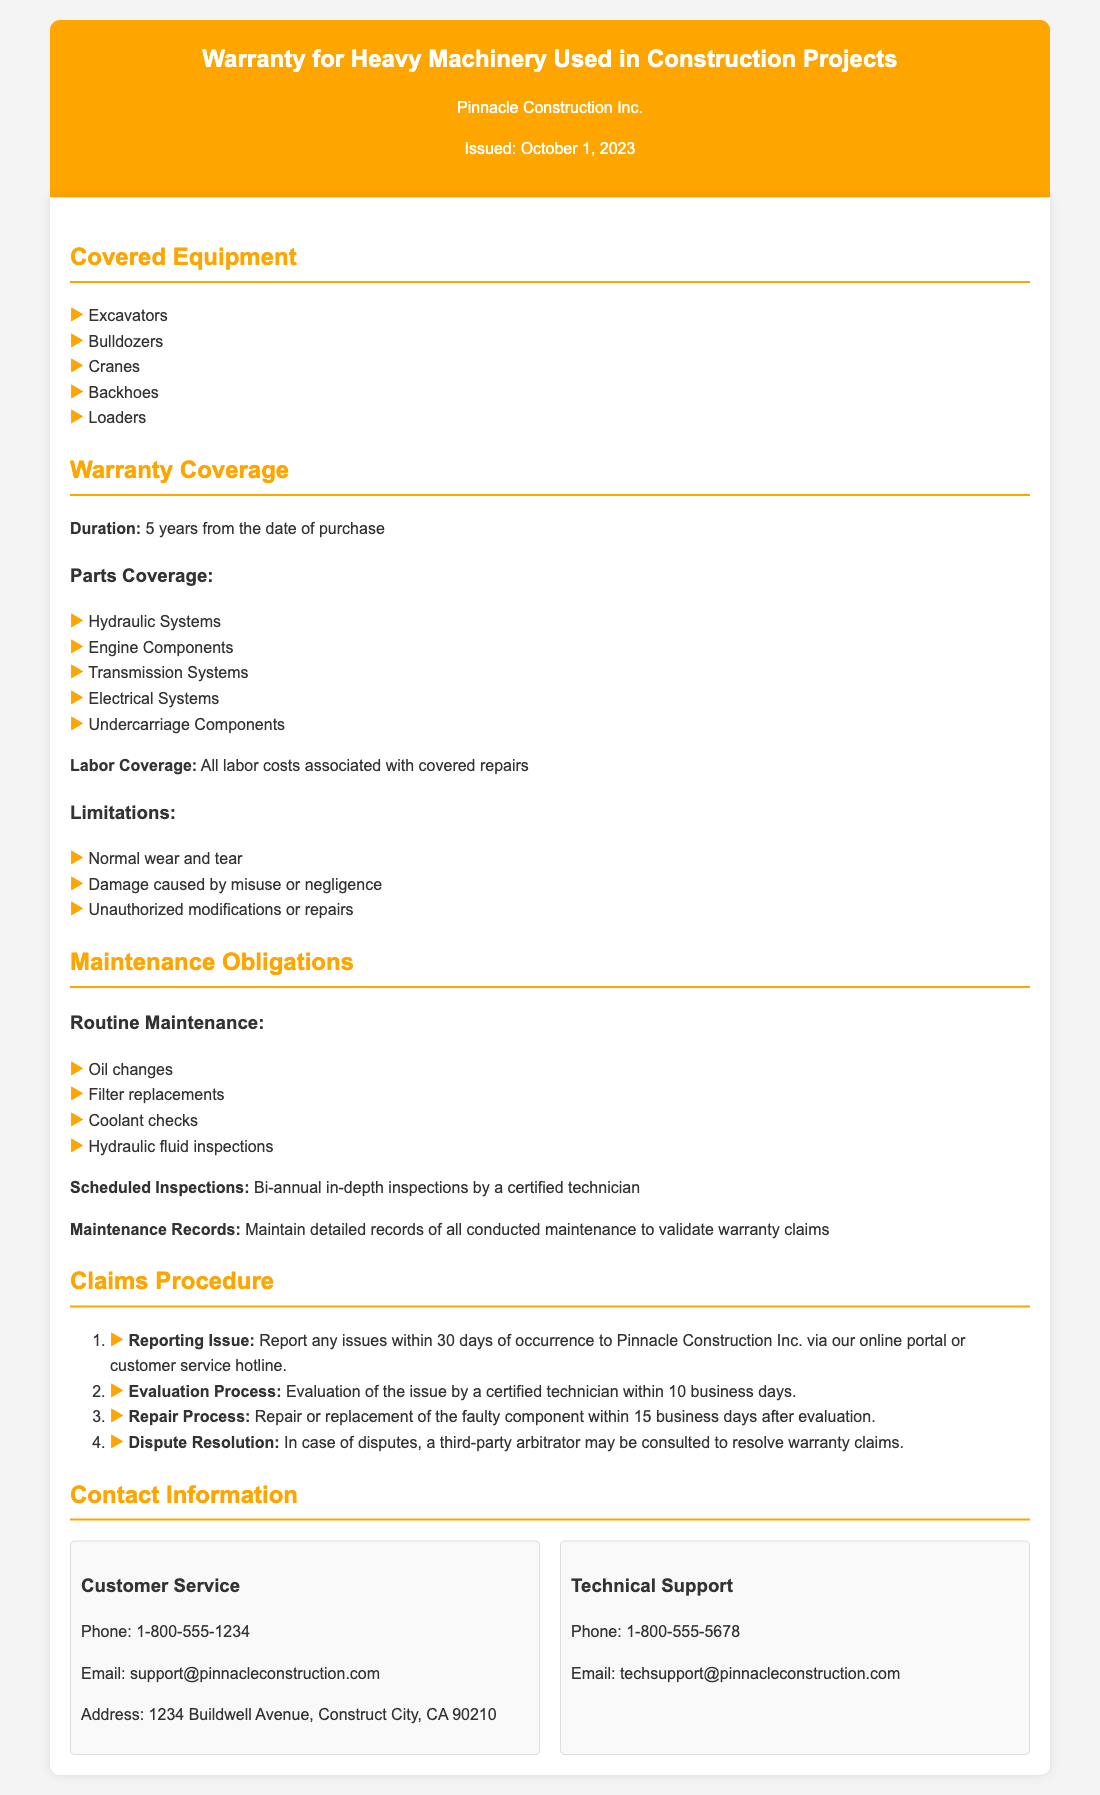what is the duration of the warranty? The duration of the warranty is stated specifically in the document.
Answer: 5 years from the date of purchase what types of equipment are covered? The document lists specific types of equipment that have coverage.
Answer: Excavators, Bulldozers, Cranes, Backhoes, Loaders what is included in labor coverage? The document specifies what labor is included under the warranty coverage.
Answer: All labor costs associated with covered repairs what is one limitation of the warranty? The document mentions specific limitations that apply to the warranty.
Answer: Normal wear and tear how often should routine maintenance be performed? The document indicates how often maintenance checks are required.
Answer: Bi-annual in-depth inspections what must be maintained to validate warranty claims? The document specifies what records need to be maintained for warranty validation.
Answer: Detailed records of all conducted maintenance how many days do you have to report an issue? The document provides a specific timeframe for reporting warranty issues.
Answer: 30 days who should issues be reported to? The document states where to report warranty issues.
Answer: Pinnacle Construction Inc. via online portal or customer service hotline what is the contact phone number for customer service? The document includes contact information including phone numbers.
Answer: 1-800-555-1234 